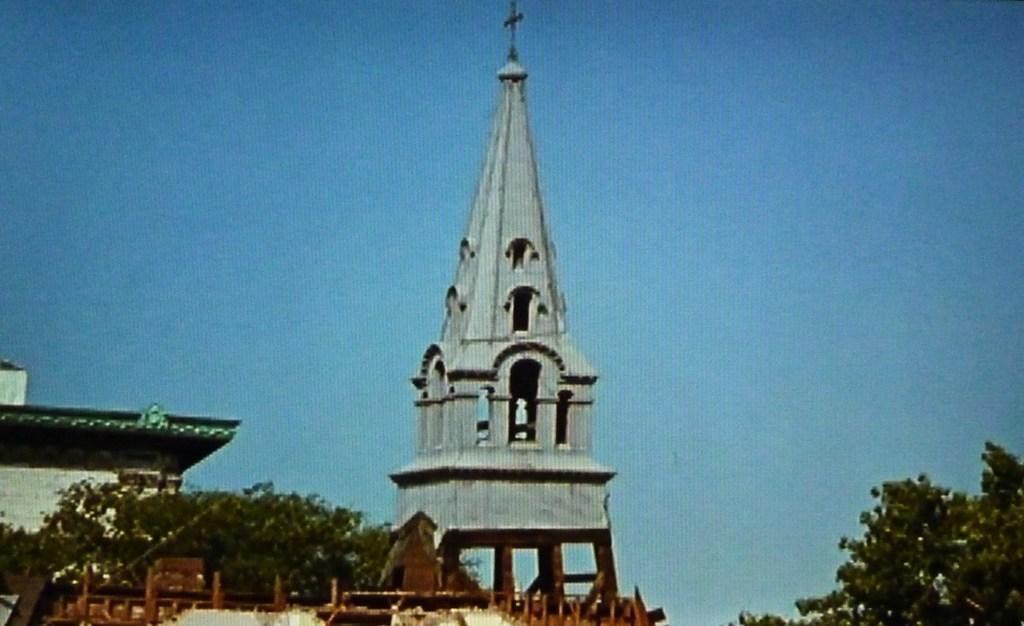Describe this image in one or two sentences. Sky is in blue color. Far there are number of trees. This is a tower and it has a cross symbol. There is a building with roof top. 